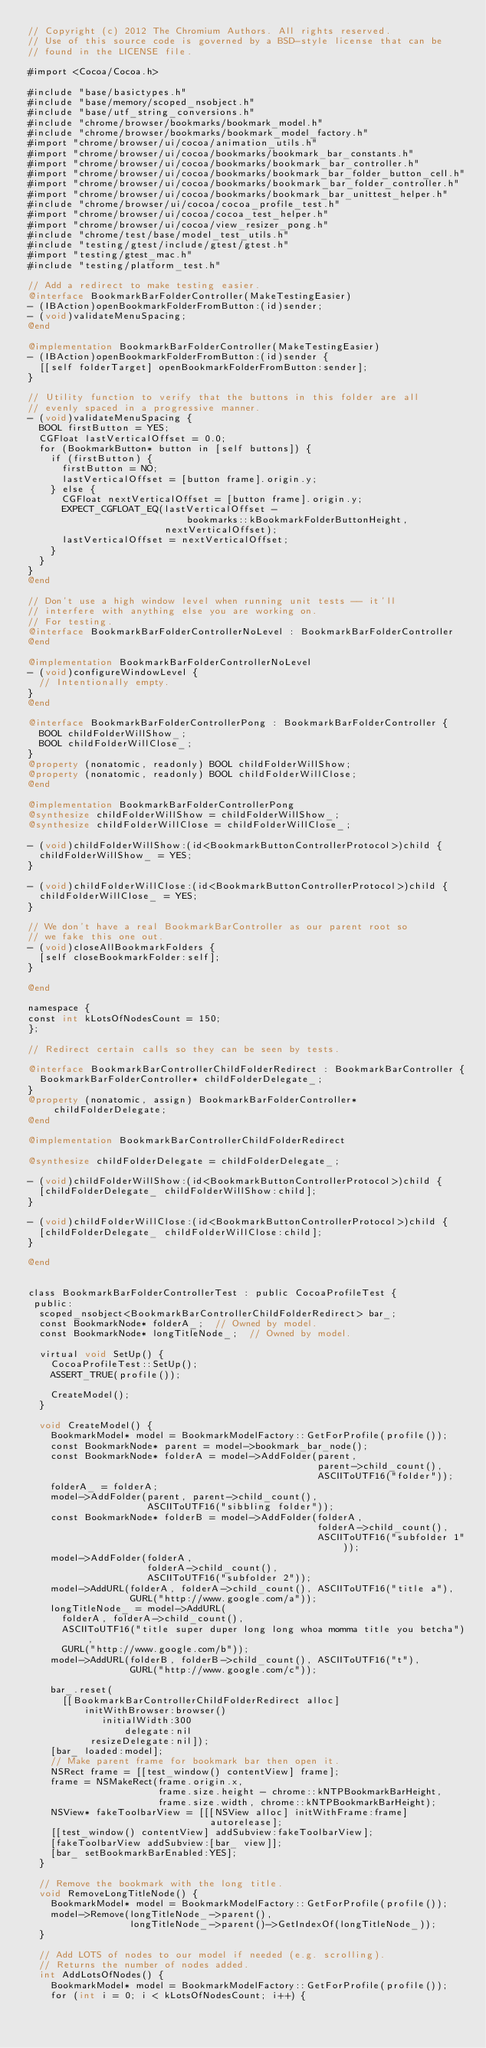Convert code to text. <code><loc_0><loc_0><loc_500><loc_500><_ObjectiveC_>// Copyright (c) 2012 The Chromium Authors. All rights reserved.
// Use of this source code is governed by a BSD-style license that can be
// found in the LICENSE file.

#import <Cocoa/Cocoa.h>

#include "base/basictypes.h"
#include "base/memory/scoped_nsobject.h"
#include "base/utf_string_conversions.h"
#include "chrome/browser/bookmarks/bookmark_model.h"
#include "chrome/browser/bookmarks/bookmark_model_factory.h"
#import "chrome/browser/ui/cocoa/animation_utils.h"
#import "chrome/browser/ui/cocoa/bookmarks/bookmark_bar_constants.h"
#import "chrome/browser/ui/cocoa/bookmarks/bookmark_bar_controller.h"
#import "chrome/browser/ui/cocoa/bookmarks/bookmark_bar_folder_button_cell.h"
#import "chrome/browser/ui/cocoa/bookmarks/bookmark_bar_folder_controller.h"
#import "chrome/browser/ui/cocoa/bookmarks/bookmark_bar_unittest_helper.h"
#include "chrome/browser/ui/cocoa/cocoa_profile_test.h"
#import "chrome/browser/ui/cocoa/cocoa_test_helper.h"
#import "chrome/browser/ui/cocoa/view_resizer_pong.h"
#include "chrome/test/base/model_test_utils.h"
#include "testing/gtest/include/gtest/gtest.h"
#import "testing/gtest_mac.h"
#include "testing/platform_test.h"

// Add a redirect to make testing easier.
@interface BookmarkBarFolderController(MakeTestingEasier)
- (IBAction)openBookmarkFolderFromButton:(id)sender;
- (void)validateMenuSpacing;
@end

@implementation BookmarkBarFolderController(MakeTestingEasier)
- (IBAction)openBookmarkFolderFromButton:(id)sender {
  [[self folderTarget] openBookmarkFolderFromButton:sender];
}

// Utility function to verify that the buttons in this folder are all
// evenly spaced in a progressive manner.
- (void)validateMenuSpacing {
  BOOL firstButton = YES;
  CGFloat lastVerticalOffset = 0.0;
  for (BookmarkButton* button in [self buttons]) {
    if (firstButton) {
      firstButton = NO;
      lastVerticalOffset = [button frame].origin.y;
    } else {
      CGFloat nextVerticalOffset = [button frame].origin.y;
      EXPECT_CGFLOAT_EQ(lastVerticalOffset -
                            bookmarks::kBookmarkFolderButtonHeight,
                        nextVerticalOffset);
      lastVerticalOffset = nextVerticalOffset;
    }
  }
}
@end

// Don't use a high window level when running unit tests -- it'll
// interfere with anything else you are working on.
// For testing.
@interface BookmarkBarFolderControllerNoLevel : BookmarkBarFolderController
@end

@implementation BookmarkBarFolderControllerNoLevel
- (void)configureWindowLevel {
  // Intentionally empty.
}
@end

@interface BookmarkBarFolderControllerPong : BookmarkBarFolderController {
  BOOL childFolderWillShow_;
  BOOL childFolderWillClose_;
}
@property (nonatomic, readonly) BOOL childFolderWillShow;
@property (nonatomic, readonly) BOOL childFolderWillClose;
@end

@implementation BookmarkBarFolderControllerPong
@synthesize childFolderWillShow = childFolderWillShow_;
@synthesize childFolderWillClose = childFolderWillClose_;

- (void)childFolderWillShow:(id<BookmarkButtonControllerProtocol>)child {
  childFolderWillShow_ = YES;
}

- (void)childFolderWillClose:(id<BookmarkButtonControllerProtocol>)child {
  childFolderWillClose_ = YES;
}

// We don't have a real BookmarkBarController as our parent root so
// we fake this one out.
- (void)closeAllBookmarkFolders {
  [self closeBookmarkFolder:self];
}

@end

namespace {
const int kLotsOfNodesCount = 150;
};

// Redirect certain calls so they can be seen by tests.

@interface BookmarkBarControllerChildFolderRedirect : BookmarkBarController {
  BookmarkBarFolderController* childFolderDelegate_;
}
@property (nonatomic, assign) BookmarkBarFolderController* childFolderDelegate;
@end

@implementation BookmarkBarControllerChildFolderRedirect

@synthesize childFolderDelegate = childFolderDelegate_;

- (void)childFolderWillShow:(id<BookmarkButtonControllerProtocol>)child {
  [childFolderDelegate_ childFolderWillShow:child];
}

- (void)childFolderWillClose:(id<BookmarkButtonControllerProtocol>)child {
  [childFolderDelegate_ childFolderWillClose:child];
}

@end


class BookmarkBarFolderControllerTest : public CocoaProfileTest {
 public:
  scoped_nsobject<BookmarkBarControllerChildFolderRedirect> bar_;
  const BookmarkNode* folderA_;  // Owned by model.
  const BookmarkNode* longTitleNode_;  // Owned by model.

  virtual void SetUp() {
    CocoaProfileTest::SetUp();
    ASSERT_TRUE(profile());

    CreateModel();
  }

  void CreateModel() {
    BookmarkModel* model = BookmarkModelFactory::GetForProfile(profile());
    const BookmarkNode* parent = model->bookmark_bar_node();
    const BookmarkNode* folderA = model->AddFolder(parent,
                                                   parent->child_count(),
                                                   ASCIIToUTF16("folder"));
    folderA_ = folderA;
    model->AddFolder(parent, parent->child_count(),
                     ASCIIToUTF16("sibbling folder"));
    const BookmarkNode* folderB = model->AddFolder(folderA,
                                                   folderA->child_count(),
                                                   ASCIIToUTF16("subfolder 1"));
    model->AddFolder(folderA,
                     folderA->child_count(),
                     ASCIIToUTF16("subfolder 2"));
    model->AddURL(folderA, folderA->child_count(), ASCIIToUTF16("title a"),
                  GURL("http://www.google.com/a"));
    longTitleNode_ = model->AddURL(
      folderA, folderA->child_count(),
      ASCIIToUTF16("title super duper long long whoa momma title you betcha"),
      GURL("http://www.google.com/b"));
    model->AddURL(folderB, folderB->child_count(), ASCIIToUTF16("t"),
                  GURL("http://www.google.com/c"));

    bar_.reset(
      [[BookmarkBarControllerChildFolderRedirect alloc]
          initWithBrowser:browser()
             initialWidth:300
                 delegate:nil
           resizeDelegate:nil]);
    [bar_ loaded:model];
    // Make parent frame for bookmark bar then open it.
    NSRect frame = [[test_window() contentView] frame];
    frame = NSMakeRect(frame.origin.x,
                       frame.size.height - chrome::kNTPBookmarkBarHeight,
                       frame.size.width, chrome::kNTPBookmarkBarHeight);
    NSView* fakeToolbarView = [[[NSView alloc] initWithFrame:frame]
                                autorelease];
    [[test_window() contentView] addSubview:fakeToolbarView];
    [fakeToolbarView addSubview:[bar_ view]];
    [bar_ setBookmarkBarEnabled:YES];
  }

  // Remove the bookmark with the long title.
  void RemoveLongTitleNode() {
    BookmarkModel* model = BookmarkModelFactory::GetForProfile(profile());
    model->Remove(longTitleNode_->parent(),
                  longTitleNode_->parent()->GetIndexOf(longTitleNode_));
  }

  // Add LOTS of nodes to our model if needed (e.g. scrolling).
  // Returns the number of nodes added.
  int AddLotsOfNodes() {
    BookmarkModel* model = BookmarkModelFactory::GetForProfile(profile());
    for (int i = 0; i < kLotsOfNodesCount; i++) {</code> 